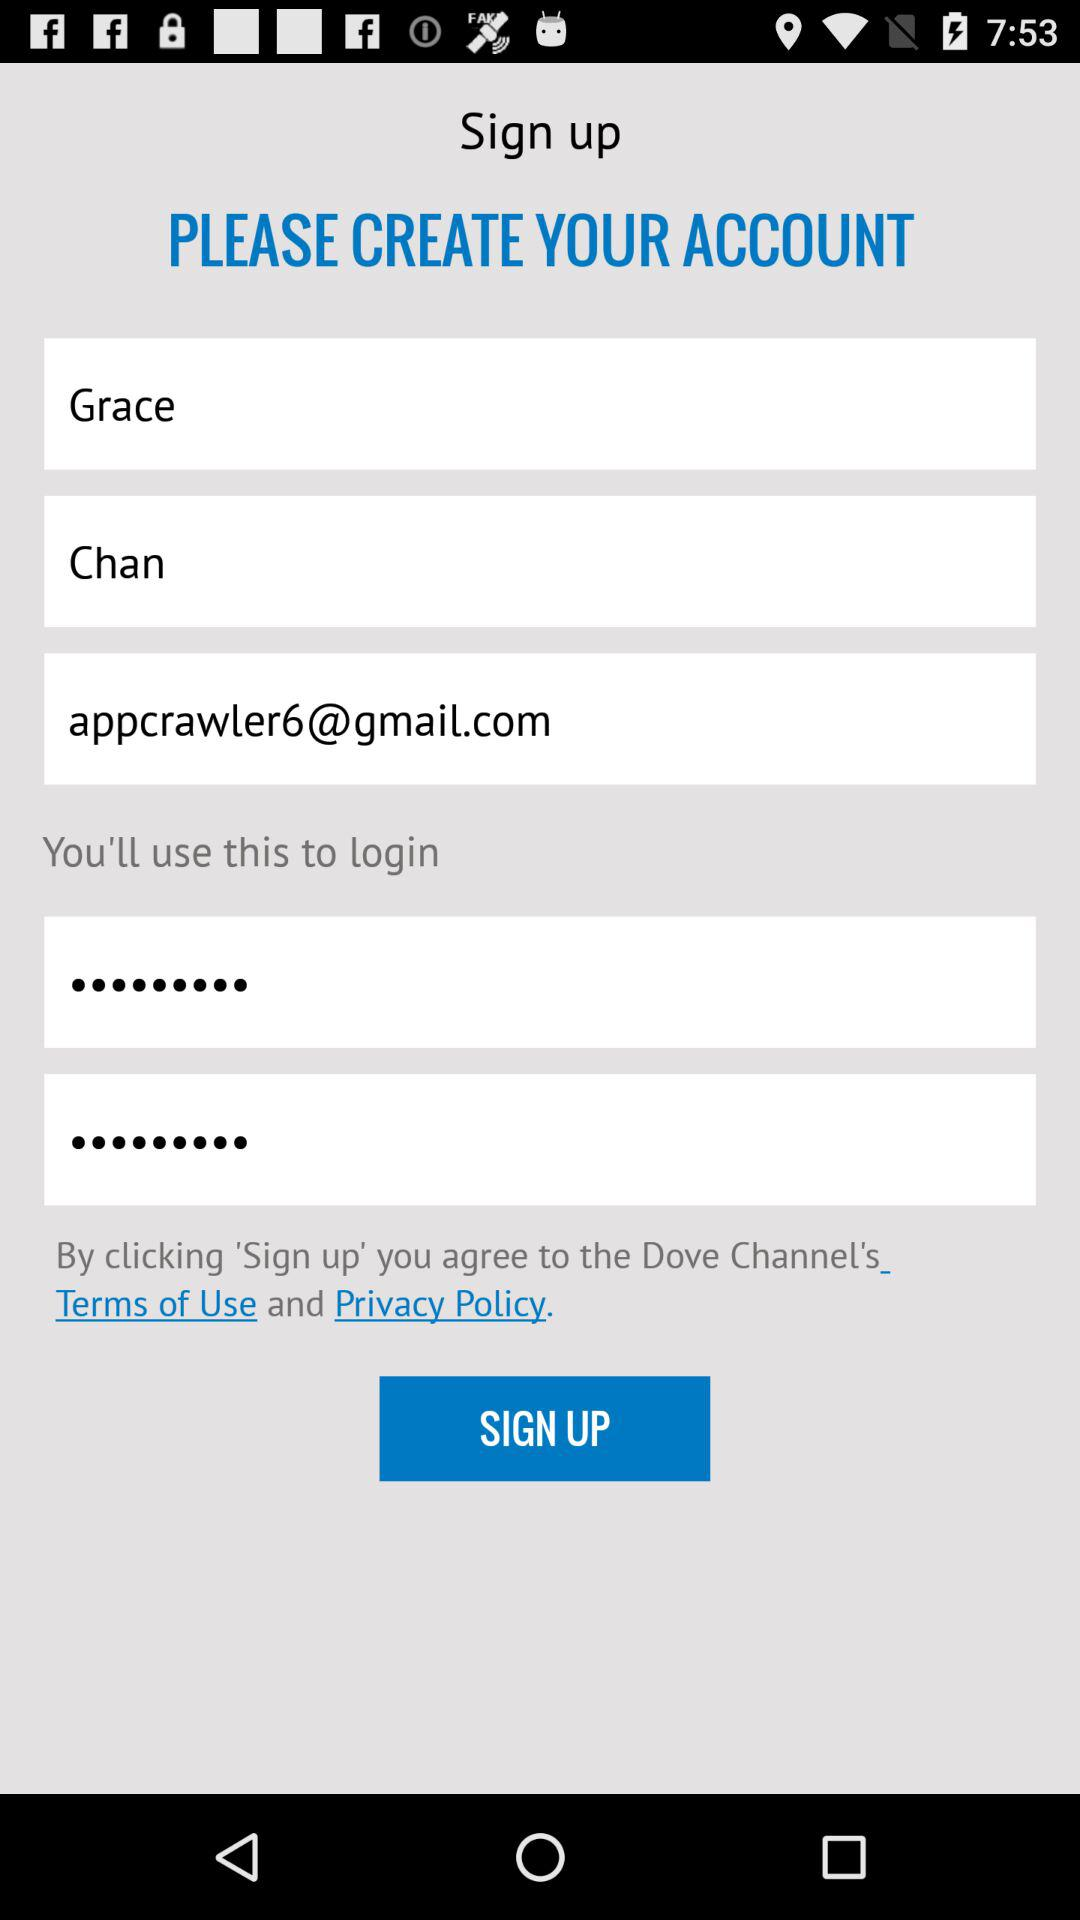What is the surname? The surname is Chan. 